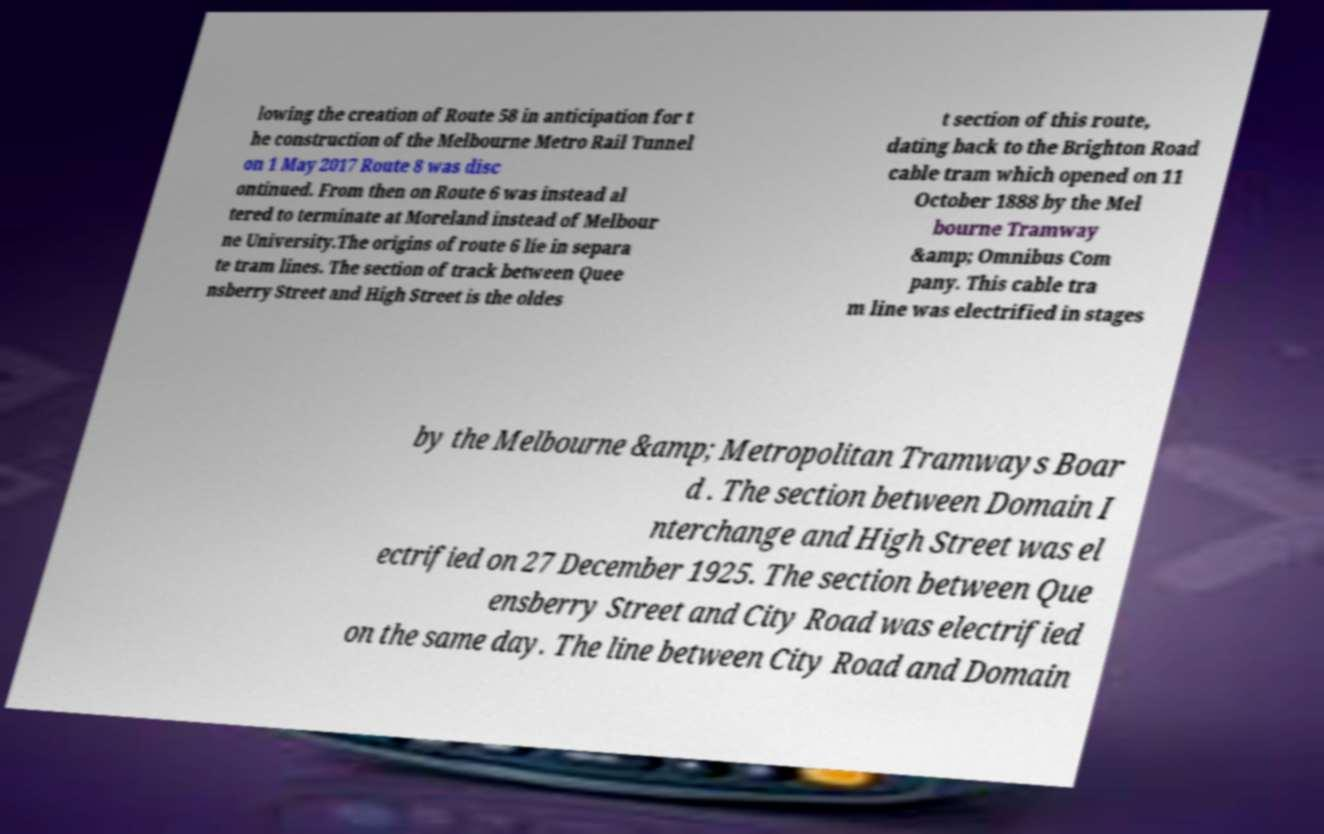What messages or text are displayed in this image? I need them in a readable, typed format. lowing the creation of Route 58 in anticipation for t he construction of the Melbourne Metro Rail Tunnel on 1 May 2017 Route 8 was disc ontinued. From then on Route 6 was instead al tered to terminate at Moreland instead of Melbour ne University.The origins of route 6 lie in separa te tram lines. The section of track between Quee nsberry Street and High Street is the oldes t section of this route, dating back to the Brighton Road cable tram which opened on 11 October 1888 by the Mel bourne Tramway &amp; Omnibus Com pany. This cable tra m line was electrified in stages by the Melbourne &amp; Metropolitan Tramways Boar d . The section between Domain I nterchange and High Street was el ectrified on 27 December 1925. The section between Que ensberry Street and City Road was electrified on the same day. The line between City Road and Domain 